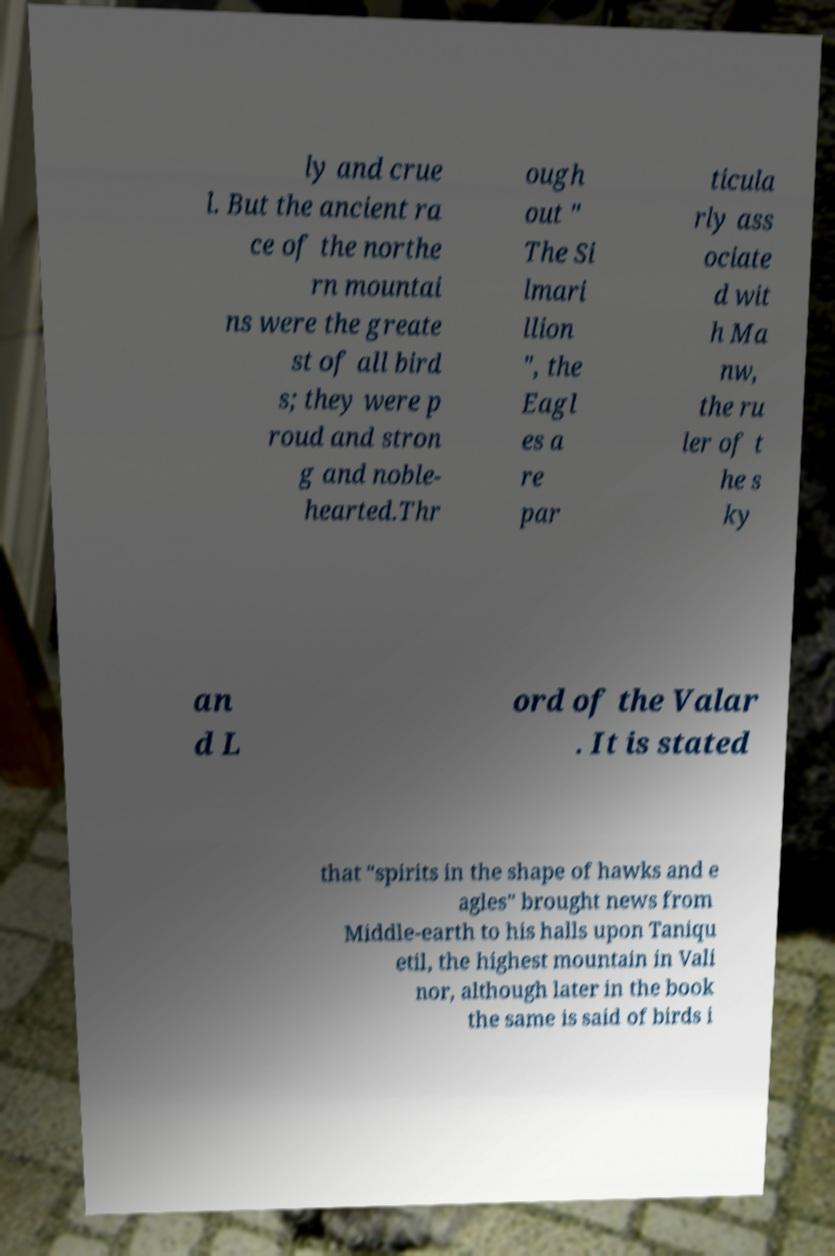What messages or text are displayed in this image? I need them in a readable, typed format. ly and crue l. But the ancient ra ce of the northe rn mountai ns were the greate st of all bird s; they were p roud and stron g and noble- hearted.Thr ough out " The Si lmari llion ", the Eagl es a re par ticula rly ass ociate d wit h Ma nw, the ru ler of t he s ky an d L ord of the Valar . It is stated that "spirits in the shape of hawks and e agles" brought news from Middle-earth to his halls upon Taniqu etil, the highest mountain in Vali nor, although later in the book the same is said of birds i 